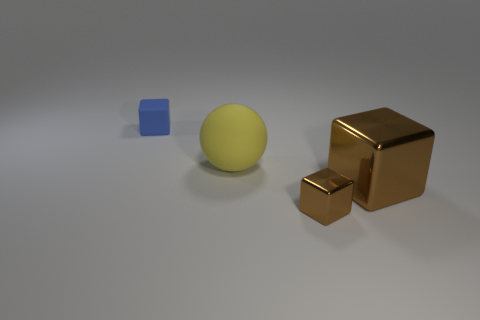How many objects does the image display, and could you describe their arrangement? The image displays a total of three objects arranged on what appears to be a neutral surface. Starting from the left, there is a small blue cube. To the right of the cube stands a yellow sphere, and further right, there are two brown metallic blocks—a larger one and a smaller one. The smaller block is in front of the larger one, creating a simple yet visually interesting arrangement. 